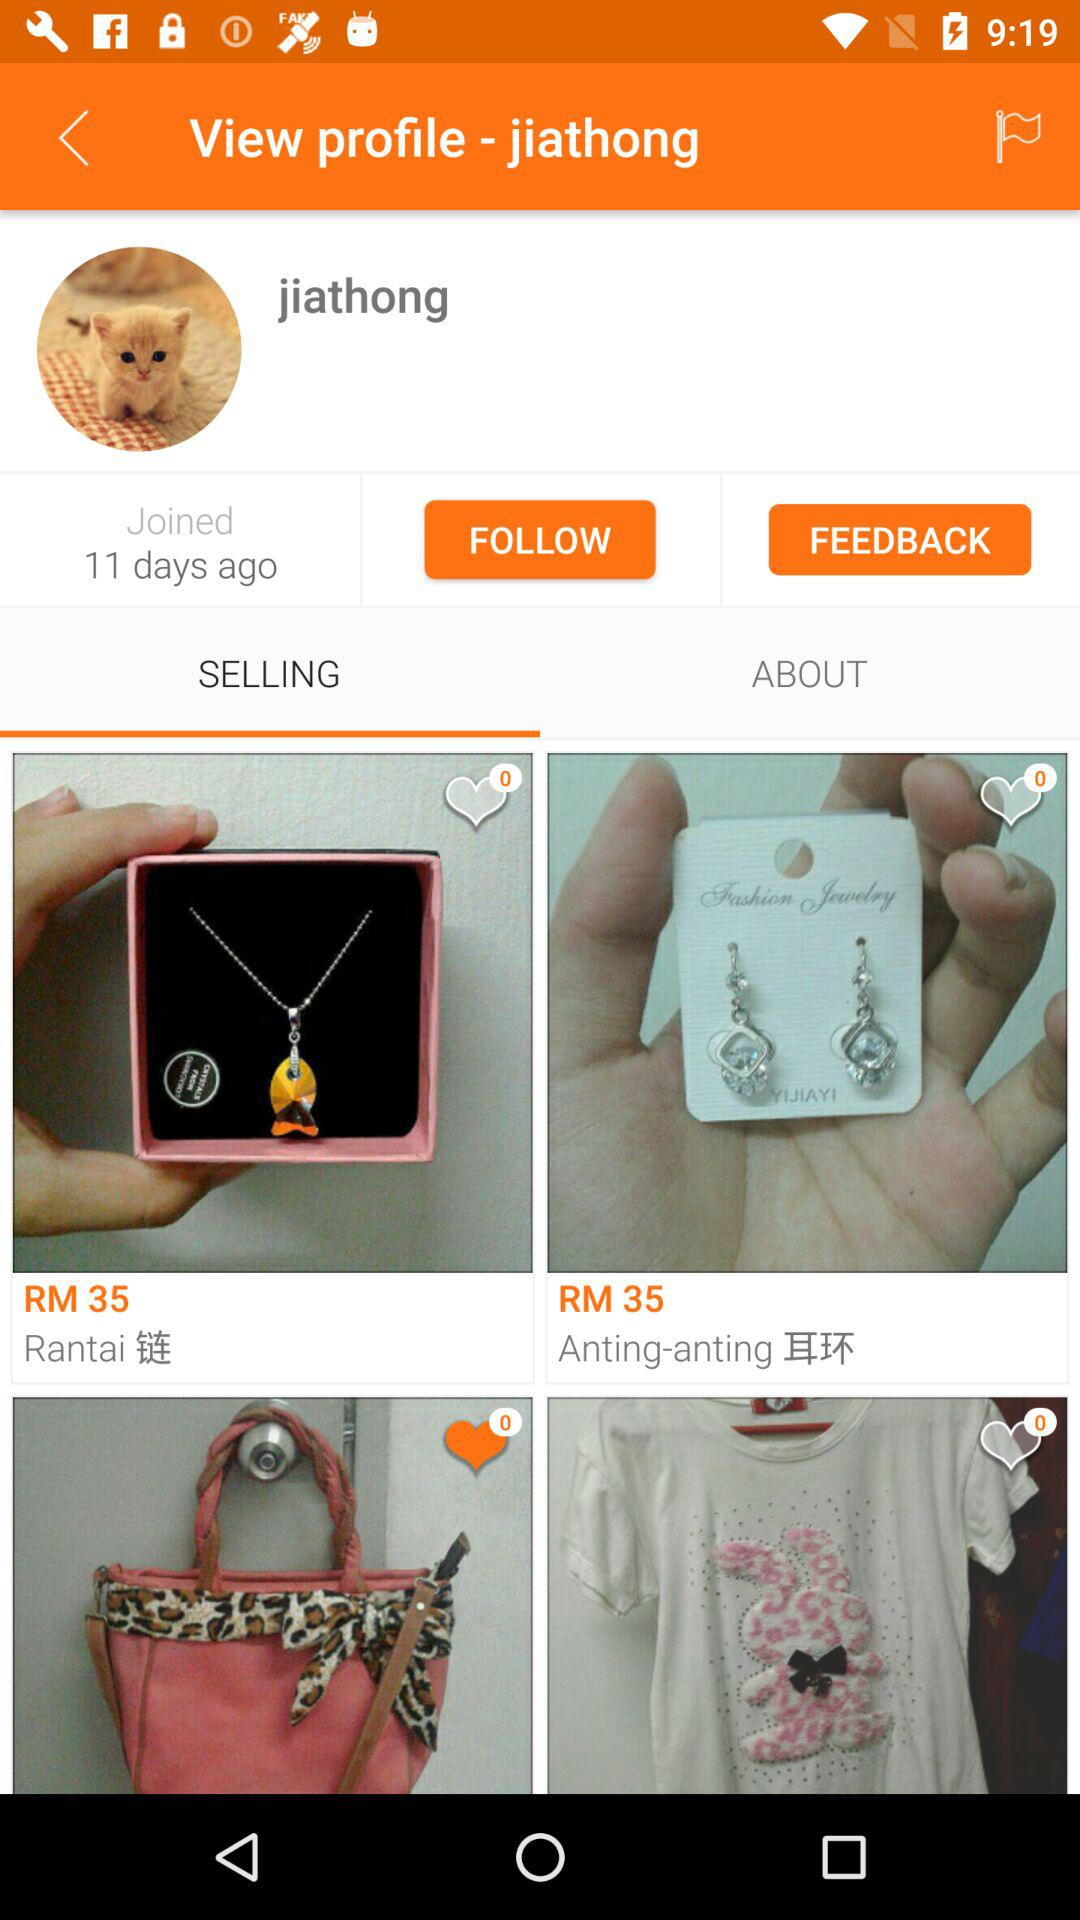How many likes are on "Rantai"? There are 0 likes. 